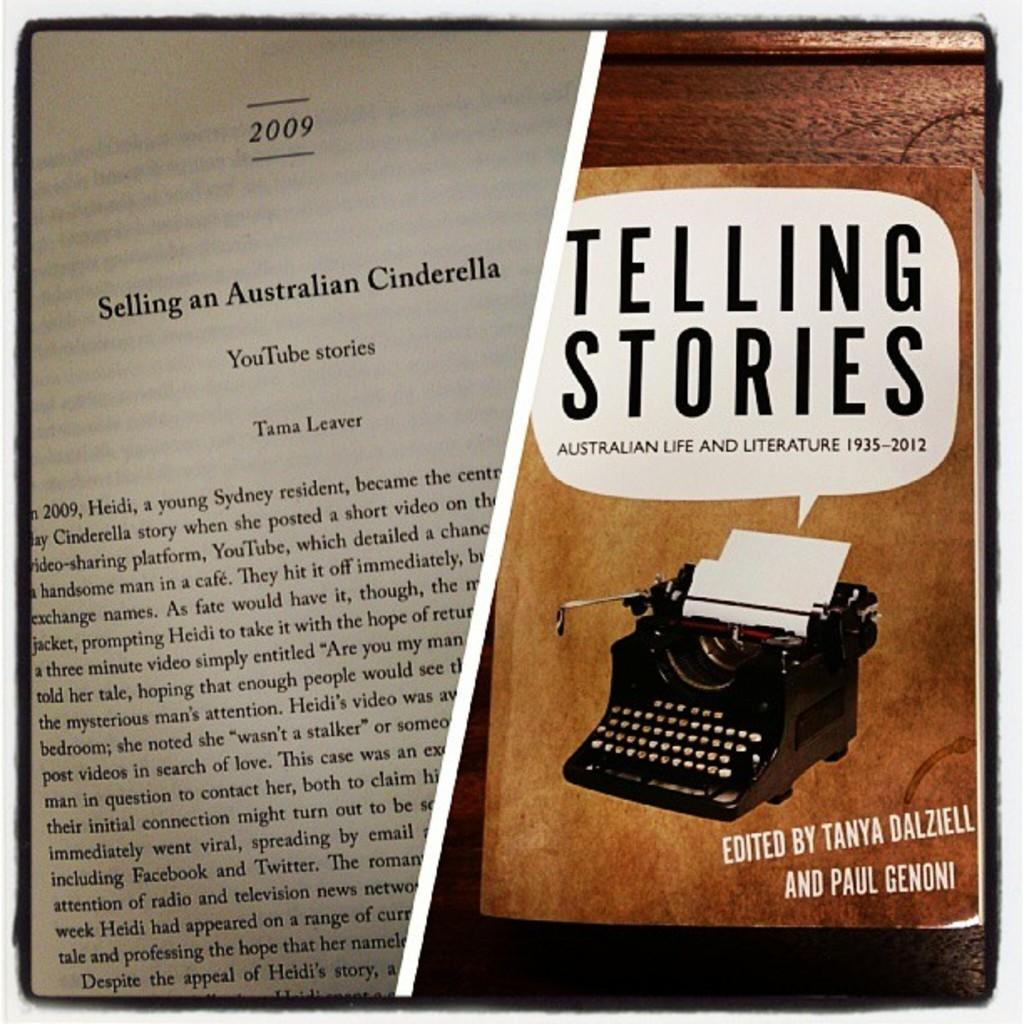<image>
Offer a succinct explanation of the picture presented. A book called Telling Stories is open to a page about YouTube stories. 